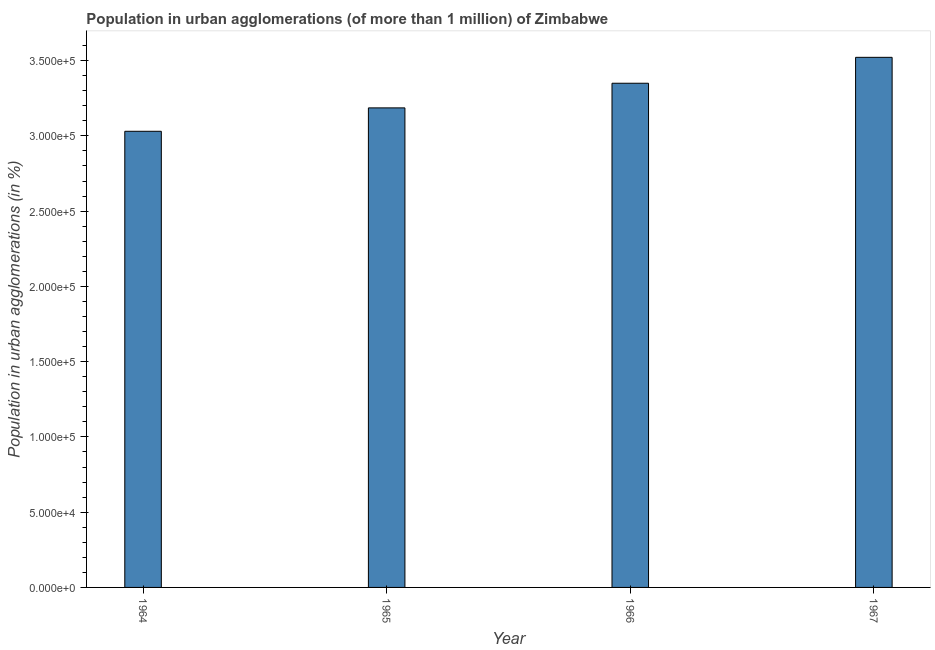Does the graph contain any zero values?
Your answer should be very brief. No. What is the title of the graph?
Keep it short and to the point. Population in urban agglomerations (of more than 1 million) of Zimbabwe. What is the label or title of the X-axis?
Your response must be concise. Year. What is the label or title of the Y-axis?
Offer a very short reply. Population in urban agglomerations (in %). What is the population in urban agglomerations in 1964?
Make the answer very short. 3.03e+05. Across all years, what is the maximum population in urban agglomerations?
Ensure brevity in your answer.  3.52e+05. Across all years, what is the minimum population in urban agglomerations?
Provide a short and direct response. 3.03e+05. In which year was the population in urban agglomerations maximum?
Make the answer very short. 1967. In which year was the population in urban agglomerations minimum?
Provide a succinct answer. 1964. What is the sum of the population in urban agglomerations?
Make the answer very short. 1.31e+06. What is the difference between the population in urban agglomerations in 1966 and 1967?
Give a very brief answer. -1.72e+04. What is the average population in urban agglomerations per year?
Offer a very short reply. 3.27e+05. What is the median population in urban agglomerations?
Your answer should be compact. 3.27e+05. Do a majority of the years between 1964 and 1967 (inclusive) have population in urban agglomerations greater than 230000 %?
Keep it short and to the point. Yes. What is the ratio of the population in urban agglomerations in 1964 to that in 1967?
Provide a succinct answer. 0.86. What is the difference between the highest and the second highest population in urban agglomerations?
Provide a succinct answer. 1.72e+04. What is the difference between the highest and the lowest population in urban agglomerations?
Give a very brief answer. 4.91e+04. How many years are there in the graph?
Provide a succinct answer. 4. What is the difference between two consecutive major ticks on the Y-axis?
Your answer should be very brief. 5.00e+04. What is the Population in urban agglomerations (in %) of 1964?
Provide a short and direct response. 3.03e+05. What is the Population in urban agglomerations (in %) in 1965?
Provide a succinct answer. 3.19e+05. What is the Population in urban agglomerations (in %) in 1966?
Provide a succinct answer. 3.35e+05. What is the Population in urban agglomerations (in %) in 1967?
Your answer should be very brief. 3.52e+05. What is the difference between the Population in urban agglomerations (in %) in 1964 and 1965?
Make the answer very short. -1.56e+04. What is the difference between the Population in urban agglomerations (in %) in 1964 and 1966?
Ensure brevity in your answer.  -3.19e+04. What is the difference between the Population in urban agglomerations (in %) in 1964 and 1967?
Your response must be concise. -4.91e+04. What is the difference between the Population in urban agglomerations (in %) in 1965 and 1966?
Your response must be concise. -1.64e+04. What is the difference between the Population in urban agglomerations (in %) in 1965 and 1967?
Your answer should be compact. -3.36e+04. What is the difference between the Population in urban agglomerations (in %) in 1966 and 1967?
Your answer should be compact. -1.72e+04. What is the ratio of the Population in urban agglomerations (in %) in 1964 to that in 1965?
Make the answer very short. 0.95. What is the ratio of the Population in urban agglomerations (in %) in 1964 to that in 1966?
Ensure brevity in your answer.  0.91. What is the ratio of the Population in urban agglomerations (in %) in 1964 to that in 1967?
Make the answer very short. 0.86. What is the ratio of the Population in urban agglomerations (in %) in 1965 to that in 1966?
Offer a very short reply. 0.95. What is the ratio of the Population in urban agglomerations (in %) in 1965 to that in 1967?
Provide a short and direct response. 0.91. What is the ratio of the Population in urban agglomerations (in %) in 1966 to that in 1967?
Your answer should be very brief. 0.95. 